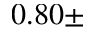<formula> <loc_0><loc_0><loc_500><loc_500>0 . 8 0 \pm</formula> 